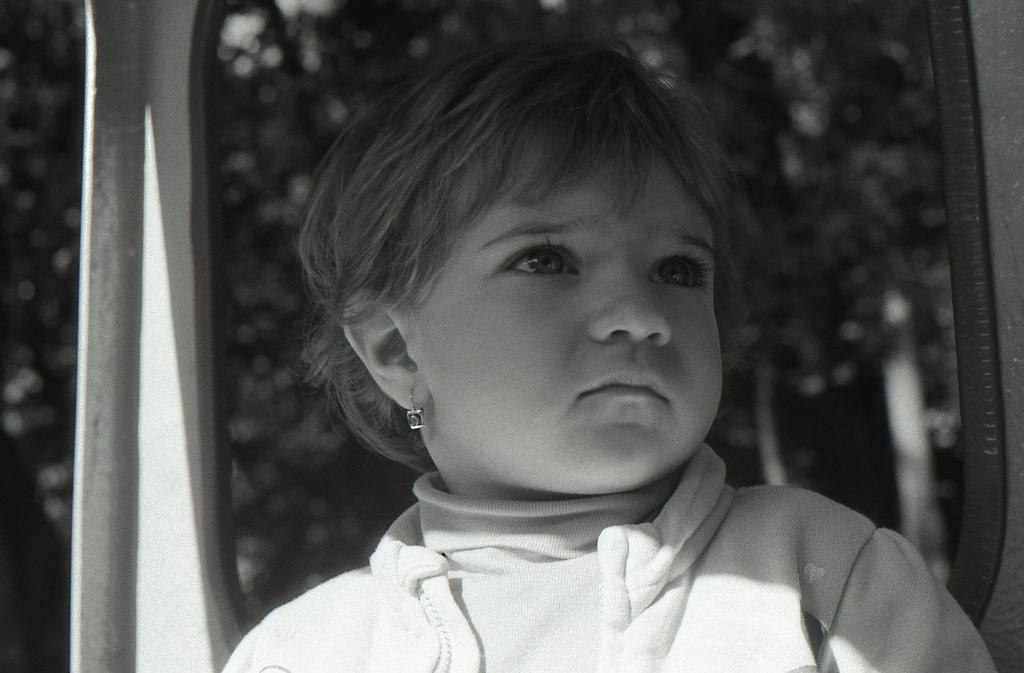What is the color scheme of the image? The image is black and white. Who or what is the main subject in the image? There is a kid in the image. What can be seen behind the kid? There are objects behind the kid. How would you describe the background of the image? The background of the image is blurred. What type of yarn is the kid using to shake the control in the image? There is no yarn, shaking, or control present in the image. 